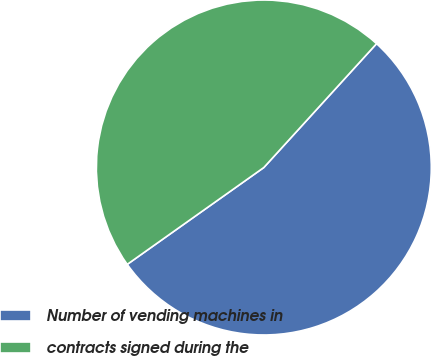Convert chart to OTSL. <chart><loc_0><loc_0><loc_500><loc_500><pie_chart><fcel>Number of vending machines in<fcel>contracts signed during the<nl><fcel>53.43%<fcel>46.57%<nl></chart> 